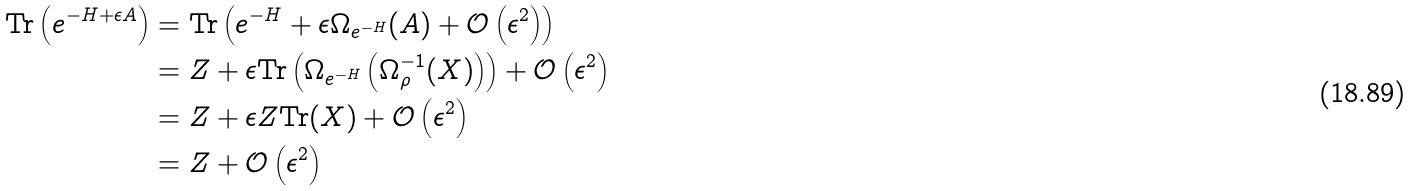<formula> <loc_0><loc_0><loc_500><loc_500>\text {Tr} \left ( e ^ { - H + \epsilon A } \right ) & = \text {Tr} \left ( e ^ { - H } + \epsilon \Omega _ { e ^ { - H } } ( A ) + \mathcal { O } \left ( \epsilon ^ { 2 } \right ) \right ) \\ & = Z + \epsilon \text {Tr} \left ( \Omega _ { e ^ { - H } } \left ( \Omega ^ { - 1 } _ { \rho } ( X ) \right ) \right ) + \mathcal { O } \left ( \epsilon ^ { 2 } \right ) \\ & = Z + \epsilon Z \text {Tr} ( X ) + \mathcal { O } \left ( \epsilon ^ { 2 } \right ) \\ & = Z + \mathcal { O } \left ( \epsilon ^ { 2 } \right )</formula> 